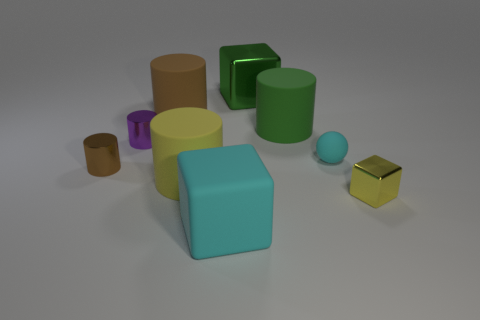Can you tell me the colors of the objects that are smaller than the cyan cube? Sure, the objects smaller than the cyan cube include a yellow cube, a brown cylinder, a green cylinder, a purple cylinder, and a blue sphere. 